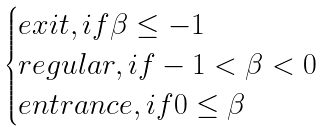Convert formula to latex. <formula><loc_0><loc_0><loc_500><loc_500>\begin{cases} e x i t , i f \beta \leq - 1 \\ r e g u l a r , i f - 1 < \beta < 0 \\ e n t r a n c e , i f 0 \leq \beta \end{cases}</formula> 